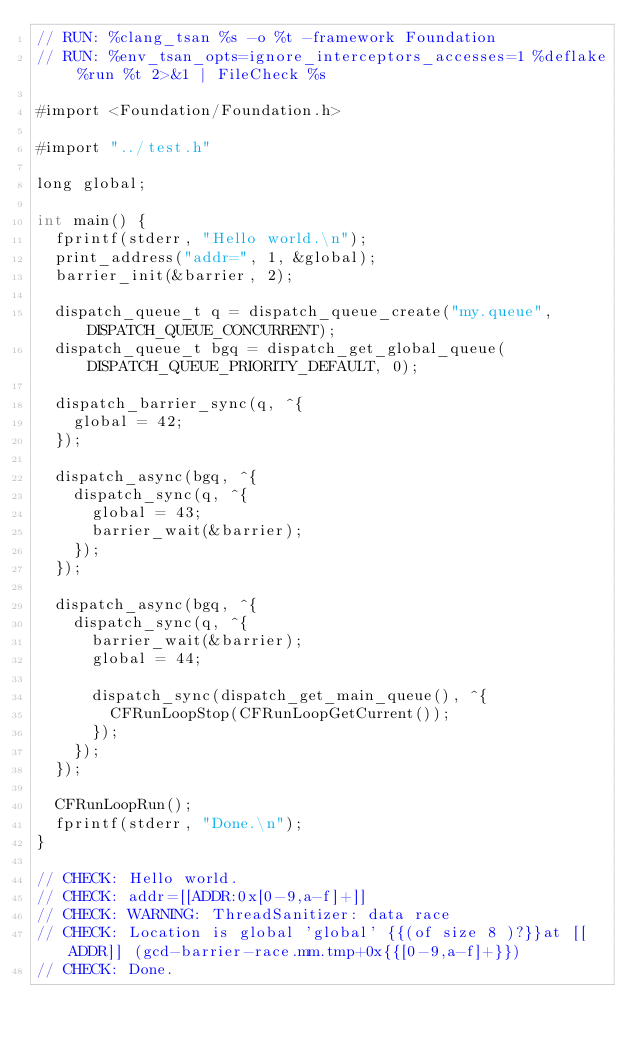<code> <loc_0><loc_0><loc_500><loc_500><_ObjectiveC_>// RUN: %clang_tsan %s -o %t -framework Foundation
// RUN: %env_tsan_opts=ignore_interceptors_accesses=1 %deflake %run %t 2>&1 | FileCheck %s

#import <Foundation/Foundation.h>

#import "../test.h"

long global;

int main() {
  fprintf(stderr, "Hello world.\n");
  print_address("addr=", 1, &global);
  barrier_init(&barrier, 2);

  dispatch_queue_t q = dispatch_queue_create("my.queue", DISPATCH_QUEUE_CONCURRENT);
  dispatch_queue_t bgq = dispatch_get_global_queue(DISPATCH_QUEUE_PRIORITY_DEFAULT, 0);

  dispatch_barrier_sync(q, ^{
    global = 42;
  });

  dispatch_async(bgq, ^{
    dispatch_sync(q, ^{
      global = 43;
      barrier_wait(&barrier);
    });
  });

  dispatch_async(bgq, ^{
    dispatch_sync(q, ^{
      barrier_wait(&barrier);
      global = 44;

      dispatch_sync(dispatch_get_main_queue(), ^{
        CFRunLoopStop(CFRunLoopGetCurrent());
      });
    });
  });

  CFRunLoopRun();
  fprintf(stderr, "Done.\n");
}

// CHECK: Hello world.
// CHECK: addr=[[ADDR:0x[0-9,a-f]+]]
// CHECK: WARNING: ThreadSanitizer: data race
// CHECK: Location is global 'global' {{(of size 8 )?}}at [[ADDR]] (gcd-barrier-race.mm.tmp+0x{{[0-9,a-f]+}})
// CHECK: Done.
</code> 